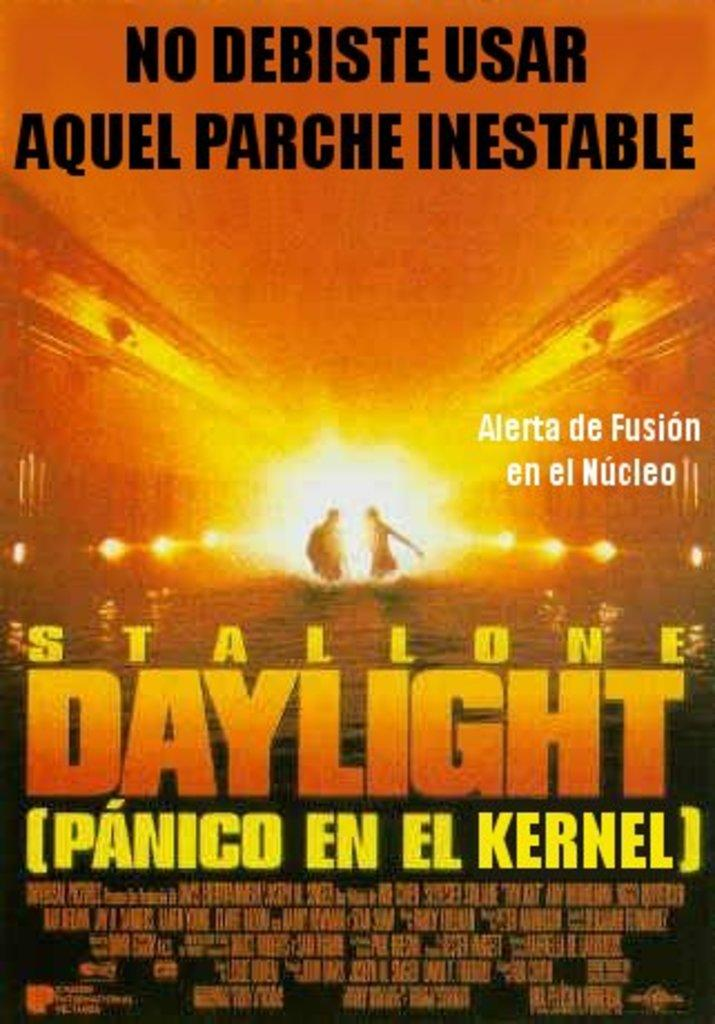<image>
Present a compact description of the photo's key features. A poster for the film Daylight starring Stallone. 